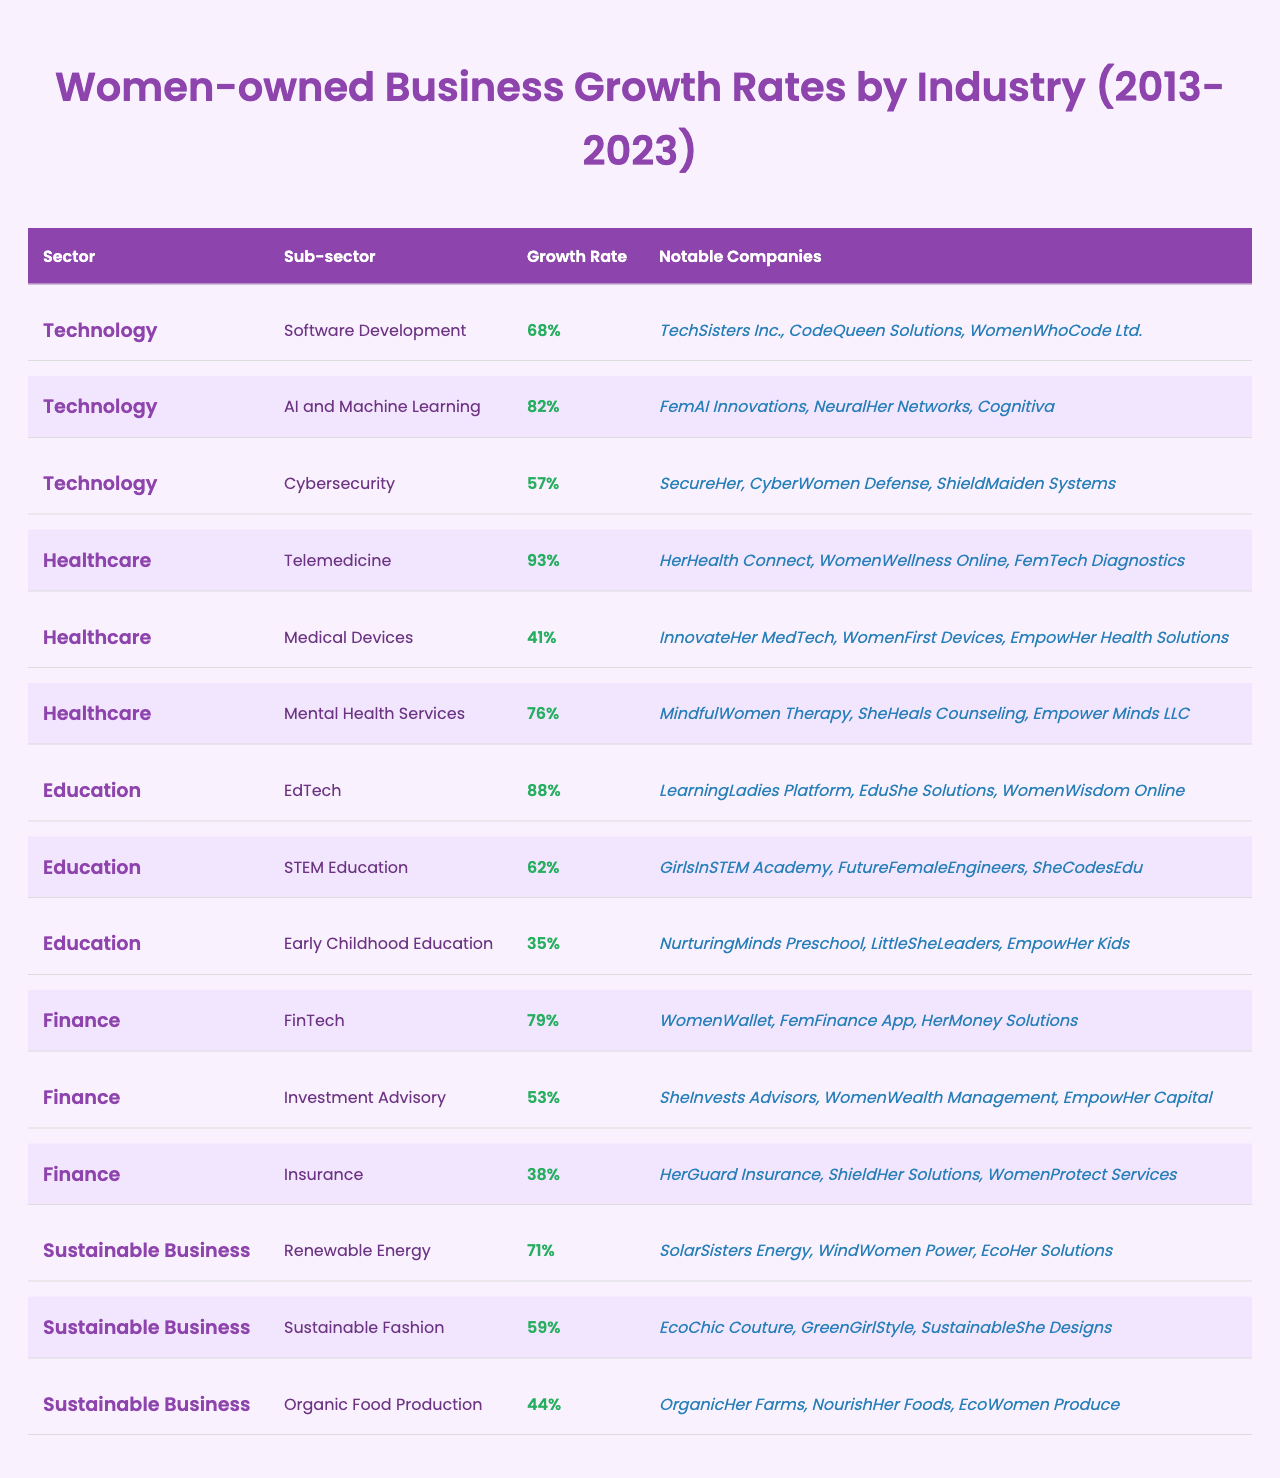What is the growth rate for the AI and Machine Learning sub-sector? The table indicates that the AI and Machine Learning sub-sector has a growth rate of 82%.
Answer: 82% Which sector has the highest growth rate? The Healthcare sector has the highest growth rate of 93% for the Telemedicine sub-sector.
Answer: Healthcare (93%) What is the growth rate difference between Software Development and Cybersecurity? Software Development has a growth rate of 68%, and Cybersecurity has a 57% growth rate. The difference is 68% - 57% = 11%.
Answer: 11% How many notable companies are listed under the Education sector? The Education sector has 3 notable companies listed under each of its 3 sub-sectors (EdTech, STEM Education, Early Childhood Education), totaling 9 notable companies.
Answer: 9 Which industry has the lowest growth rate according to the table? The Early Childhood Education sub-sector has the lowest growth rate of 35%.
Answer: Early Childhood Education (35%) Are there any companies listed under the Sustainable Business sector? Yes, there are notable companies listed under the Sustainable Business sector, such as SolarSisters Energy and EcoHer Solutions.
Answer: Yes What is the average growth rate for the Finance sector? The Finance sector comprises three sub-sectors with growth rates of 79% (FinTech), 53% (Investment Advisory), and 38% (Insurance). The average growth rate is (79 + 53 + 38)/3 = 56.67%.
Answer: 56.67% Which sub-sector has a notable company named "Cognitiva"? Cognitiva is a notable company under the AI and Machine Learning sub-sector, which has a growth rate of 82%.
Answer: AI and Machine Learning If we combine the growth rates for all sub-sectors in the Sustainable Business sector, what is the sum? The growth rates for the Sustainable Business sector are 71% (Renewable Energy), 59% (Sustainable Fashion), and 44% (Organic Food Production). The sum is 71% + 59% + 44% = 174%.
Answer: 174% Is there a sector where all its sub-sectors have a growth rate above 50%? Yes, both the Technology and Healthcare sectors have all their sub-sectors with growth rates above 50%.
Answer: Yes 